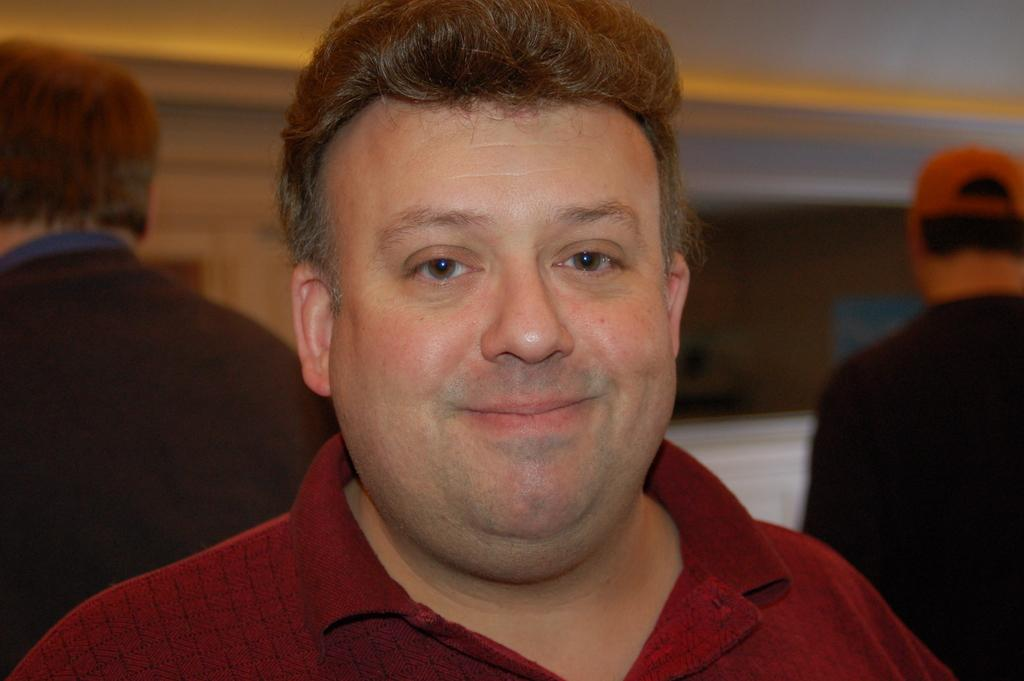How many people are in the image? There are people in the image. Can you describe any specific clothing item worn by one of the people? One of the people is wearing a cap. What type of structure is visible in the image? There is a wall in the image. What type of smoke can be seen coming from the bottle in the image? There is no bottle or smoke present in the image. Is there a crook visible in the image? There is no crook present in the image. 